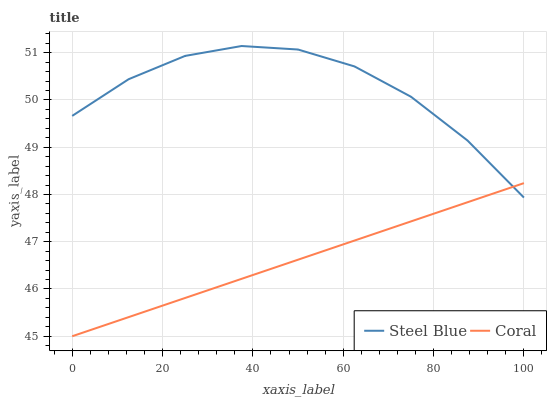Does Coral have the minimum area under the curve?
Answer yes or no. Yes. Does Steel Blue have the maximum area under the curve?
Answer yes or no. Yes. Does Steel Blue have the minimum area under the curve?
Answer yes or no. No. Is Coral the smoothest?
Answer yes or no. Yes. Is Steel Blue the roughest?
Answer yes or no. Yes. Is Steel Blue the smoothest?
Answer yes or no. No. Does Coral have the lowest value?
Answer yes or no. Yes. Does Steel Blue have the lowest value?
Answer yes or no. No. Does Steel Blue have the highest value?
Answer yes or no. Yes. Does Coral intersect Steel Blue?
Answer yes or no. Yes. Is Coral less than Steel Blue?
Answer yes or no. No. Is Coral greater than Steel Blue?
Answer yes or no. No. 